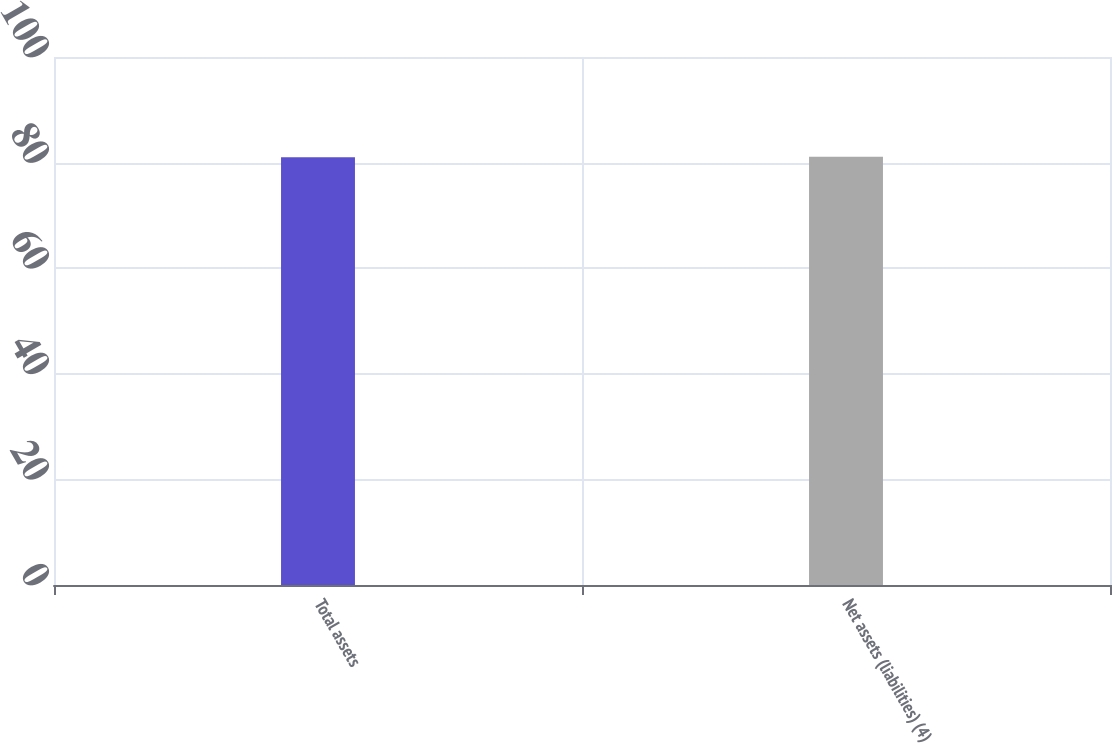Convert chart. <chart><loc_0><loc_0><loc_500><loc_500><bar_chart><fcel>Total assets<fcel>Net assets (liabilities) (4)<nl><fcel>81<fcel>81.1<nl></chart> 